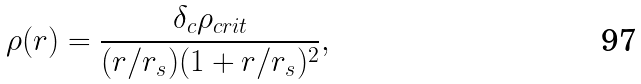<formula> <loc_0><loc_0><loc_500><loc_500>\rho ( r ) = \frac { \delta _ { c } \rho _ { c r i t } } { ( r / r _ { s } ) ( 1 + r / r _ { s } ) ^ { 2 } } , \\</formula> 